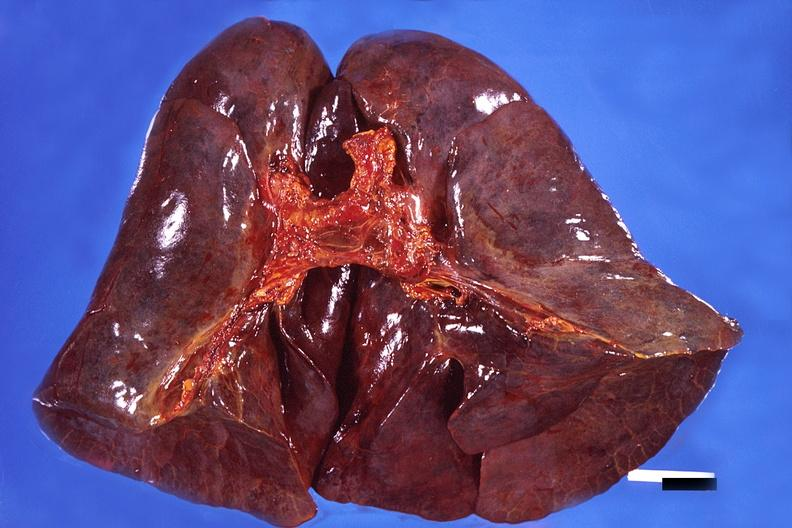what does this image show?
Answer the question using a single word or phrase. Lung 